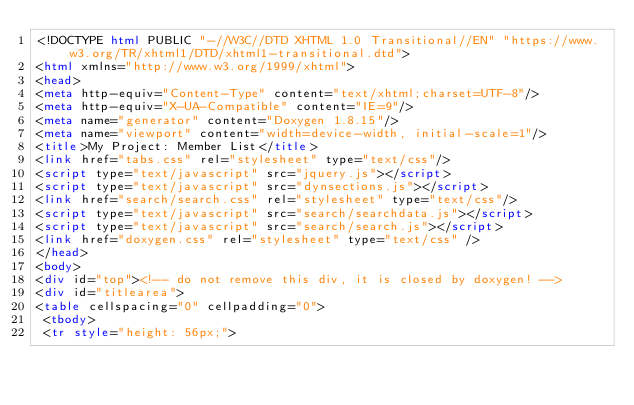<code> <loc_0><loc_0><loc_500><loc_500><_HTML_><!DOCTYPE html PUBLIC "-//W3C//DTD XHTML 1.0 Transitional//EN" "https://www.w3.org/TR/xhtml1/DTD/xhtml1-transitional.dtd">
<html xmlns="http://www.w3.org/1999/xhtml">
<head>
<meta http-equiv="Content-Type" content="text/xhtml;charset=UTF-8"/>
<meta http-equiv="X-UA-Compatible" content="IE=9"/>
<meta name="generator" content="Doxygen 1.8.15"/>
<meta name="viewport" content="width=device-width, initial-scale=1"/>
<title>My Project: Member List</title>
<link href="tabs.css" rel="stylesheet" type="text/css"/>
<script type="text/javascript" src="jquery.js"></script>
<script type="text/javascript" src="dynsections.js"></script>
<link href="search/search.css" rel="stylesheet" type="text/css"/>
<script type="text/javascript" src="search/searchdata.js"></script>
<script type="text/javascript" src="search/search.js"></script>
<link href="doxygen.css" rel="stylesheet" type="text/css" />
</head>
<body>
<div id="top"><!-- do not remove this div, it is closed by doxygen! -->
<div id="titlearea">
<table cellspacing="0" cellpadding="0">
 <tbody>
 <tr style="height: 56px;"></code> 